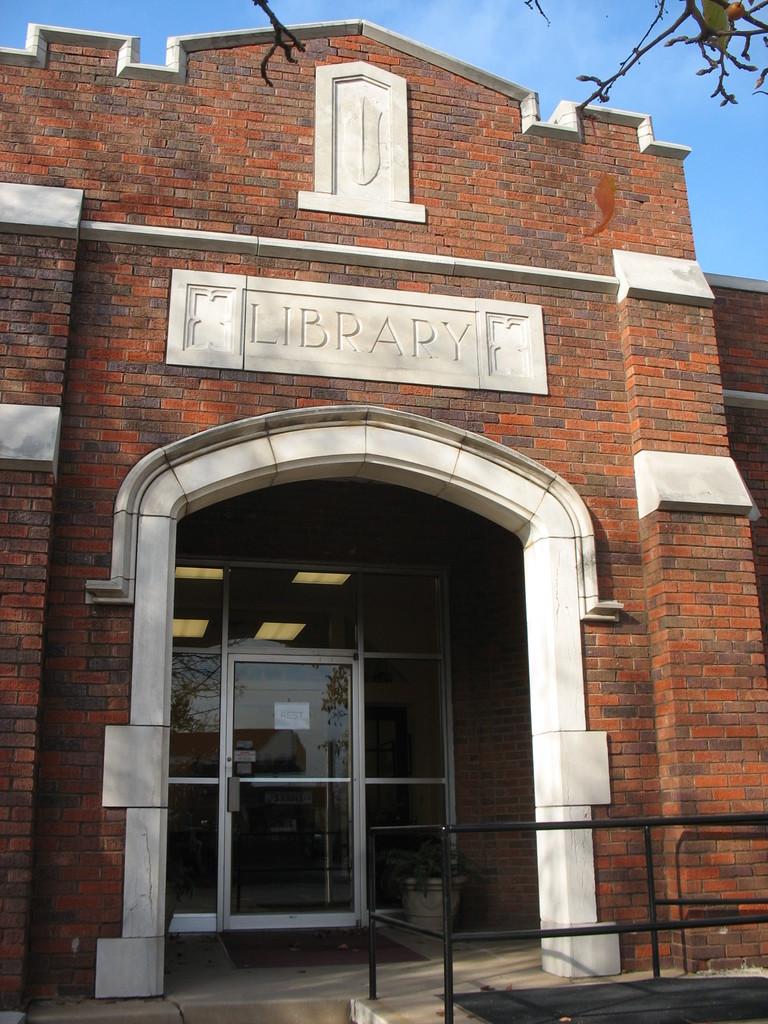What type of building is this?
Make the answer very short. Library. Ehat is this building?
Offer a very short reply. Library. 